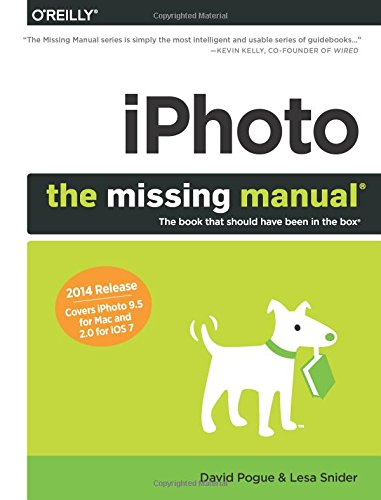Is this book related to Education & Teaching? No, this book is focused on Computers & Technology, specifically on providing users with an understanding and operational knowledge of the iPhoto software, and does not deal with general education or teaching methodologies. 